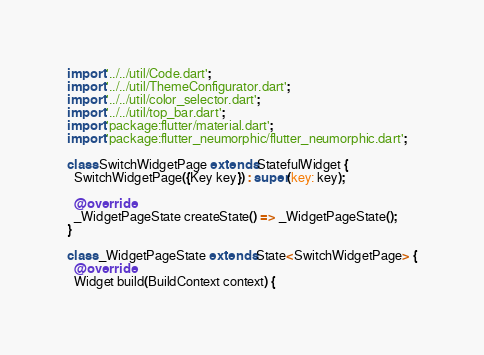<code> <loc_0><loc_0><loc_500><loc_500><_Dart_>import '../../util/Code.dart';
import '../../util/ThemeConfigurator.dart';
import '../../util/color_selector.dart';
import '../../util/top_bar.dart';
import 'package:flutter/material.dart';
import 'package:flutter_neumorphic/flutter_neumorphic.dart';

class SwitchWidgetPage extends StatefulWidget {
  SwitchWidgetPage({Key key}) : super(key: key);

  @override
  _WidgetPageState createState() => _WidgetPageState();
}

class _WidgetPageState extends State<SwitchWidgetPage> {
  @override
  Widget build(BuildContext context) {</code> 